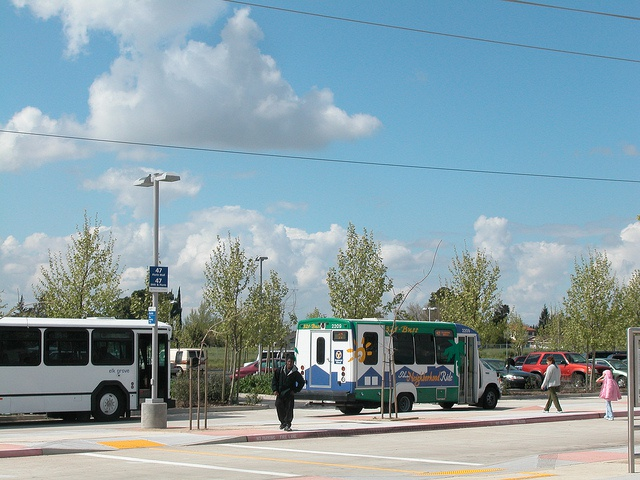Describe the objects in this image and their specific colors. I can see bus in lightblue, black, darkgray, gray, and white tones, bus in lightblue, black, darkgray, gray, and white tones, car in lightblue, gray, black, salmon, and brown tones, people in lightblue, black, gray, and darkgray tones, and car in lightblue, black, gray, and blue tones in this image. 